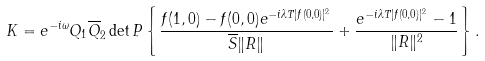<formula> <loc_0><loc_0><loc_500><loc_500>K = e ^ { - i \omega } Q _ { 1 } \overline { Q } _ { 2 } \det P \left \{ \frac { f ( 1 , 0 ) - f ( 0 , 0 ) e ^ { - i \lambda T | f ( 0 , 0 ) | ^ { 2 } } } { \overline { S } \| R \| } + \frac { e ^ { - i \lambda T | f ( 0 , 0 ) | ^ { 2 } } - 1 } { \| R \| ^ { 2 } } \right \} .</formula> 